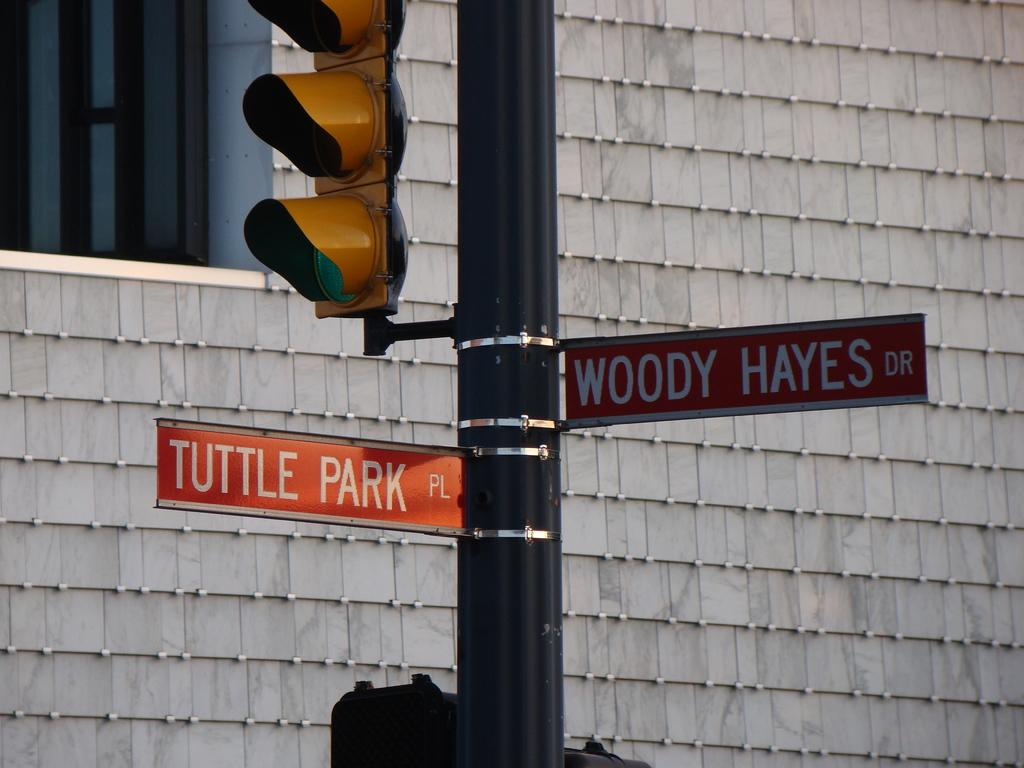<image>
Render a clear and concise summary of the photo. tuttle park is on a sign next to woody hayes 